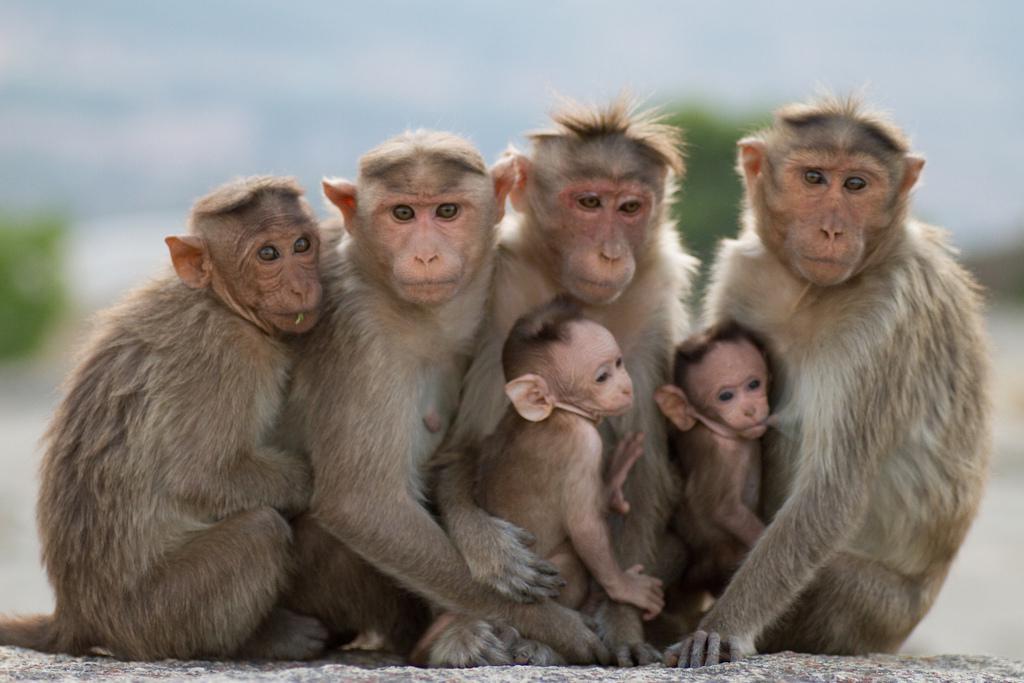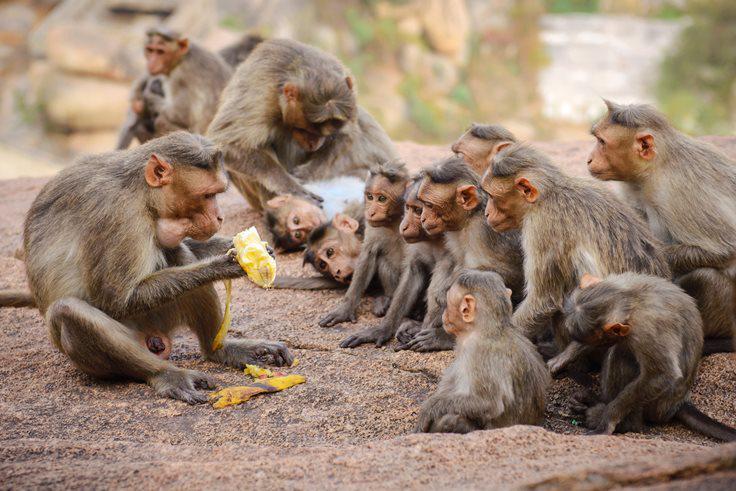The first image is the image on the left, the second image is the image on the right. For the images shown, is this caption "There are no more than 6 monkeys in the image on the left." true? Answer yes or no. Yes. 